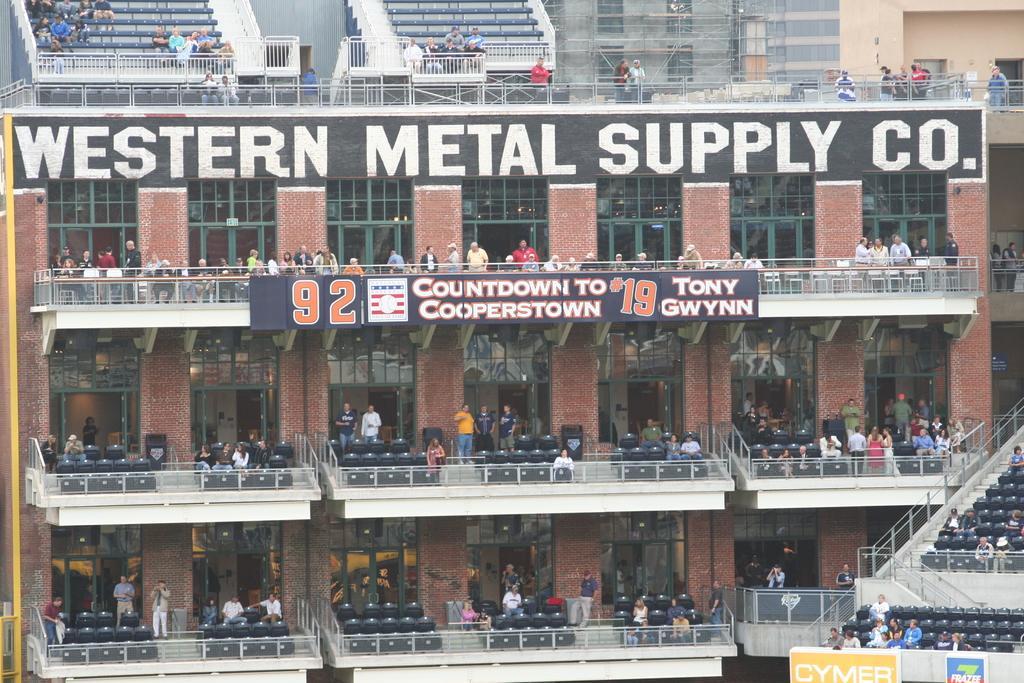Describe this image in one or two sentences. This is the picture of a building. In this image there are group of people sitting on the chairs behind the railing. There are group of people standing. There are hoardings on the buildings. There is a text on the building. On the right side of the image there is a staircase. On the left side of the image there is a pole. 